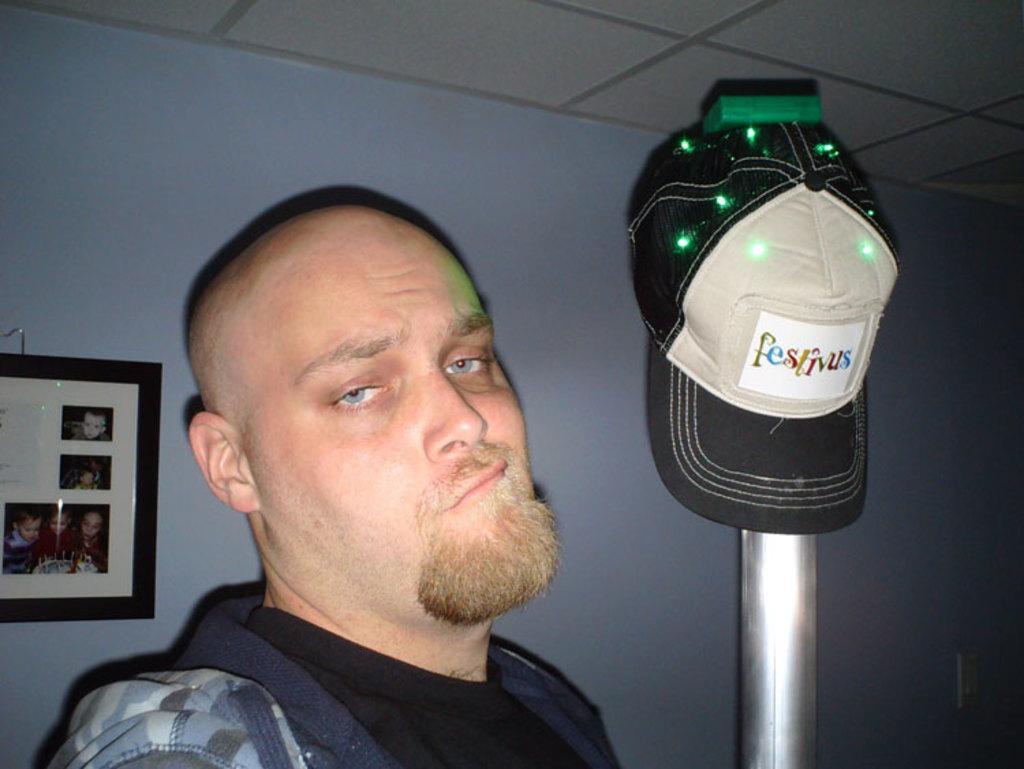Could you give a brief overview of what you see in this image? There is one person at the bottom of this image. There is one cap kept on a rod as we can see on the right side of this image. There is a wall in the background. There is one photo frame is attached onto this wall. 